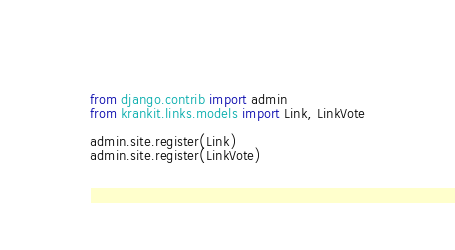Convert code to text. <code><loc_0><loc_0><loc_500><loc_500><_Python_>from django.contrib import admin
from krankit.links.models import Link, LinkVote

admin.site.register(Link)
admin.site.register(LinkVote)
</code> 